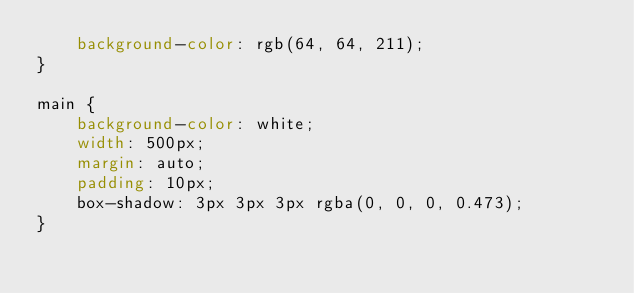<code> <loc_0><loc_0><loc_500><loc_500><_CSS_>    background-color: rgb(64, 64, 211);
}

main {
    background-color: white;
    width: 500px;
    margin: auto;
    padding: 10px;
    box-shadow: 3px 3px 3px rgba(0, 0, 0, 0.473);
}</code> 